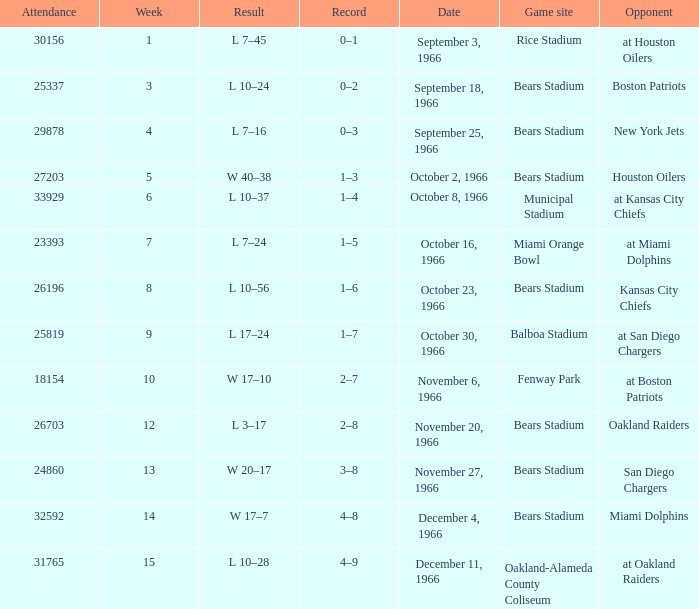How many results are listed for week 13? 1.0. 